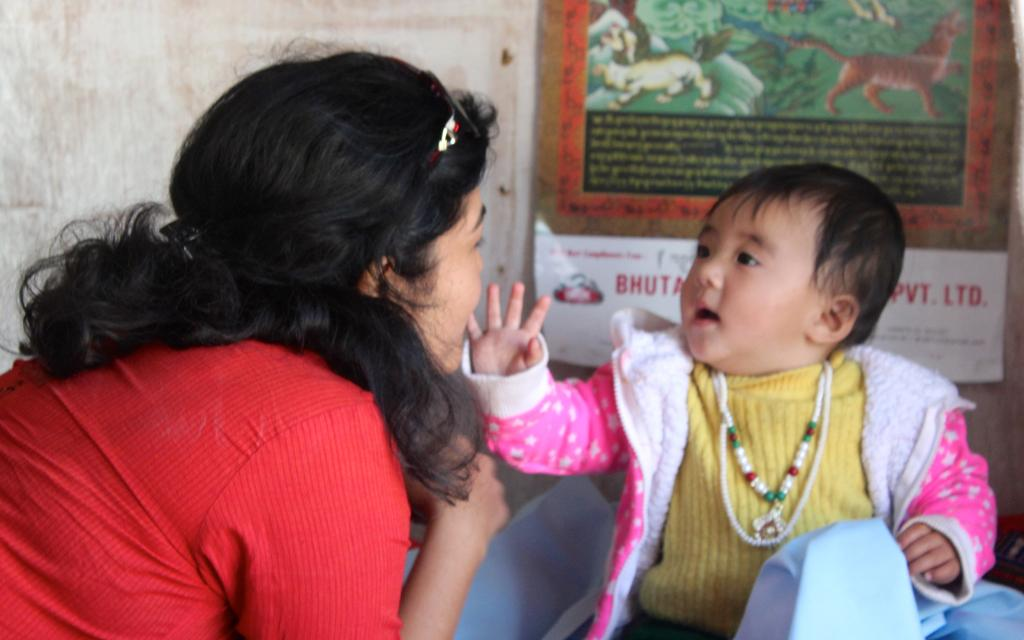How many people are present in the image? There are two people in the image. What else can be seen in the image besides the people? There is a poster in the image. What is the color of the wall in the image? The wall in the image is white. Can you tell me what verse is written on the poster in the image? There is no verse present on the poster in the image; it is not mentioned in the provided facts. 